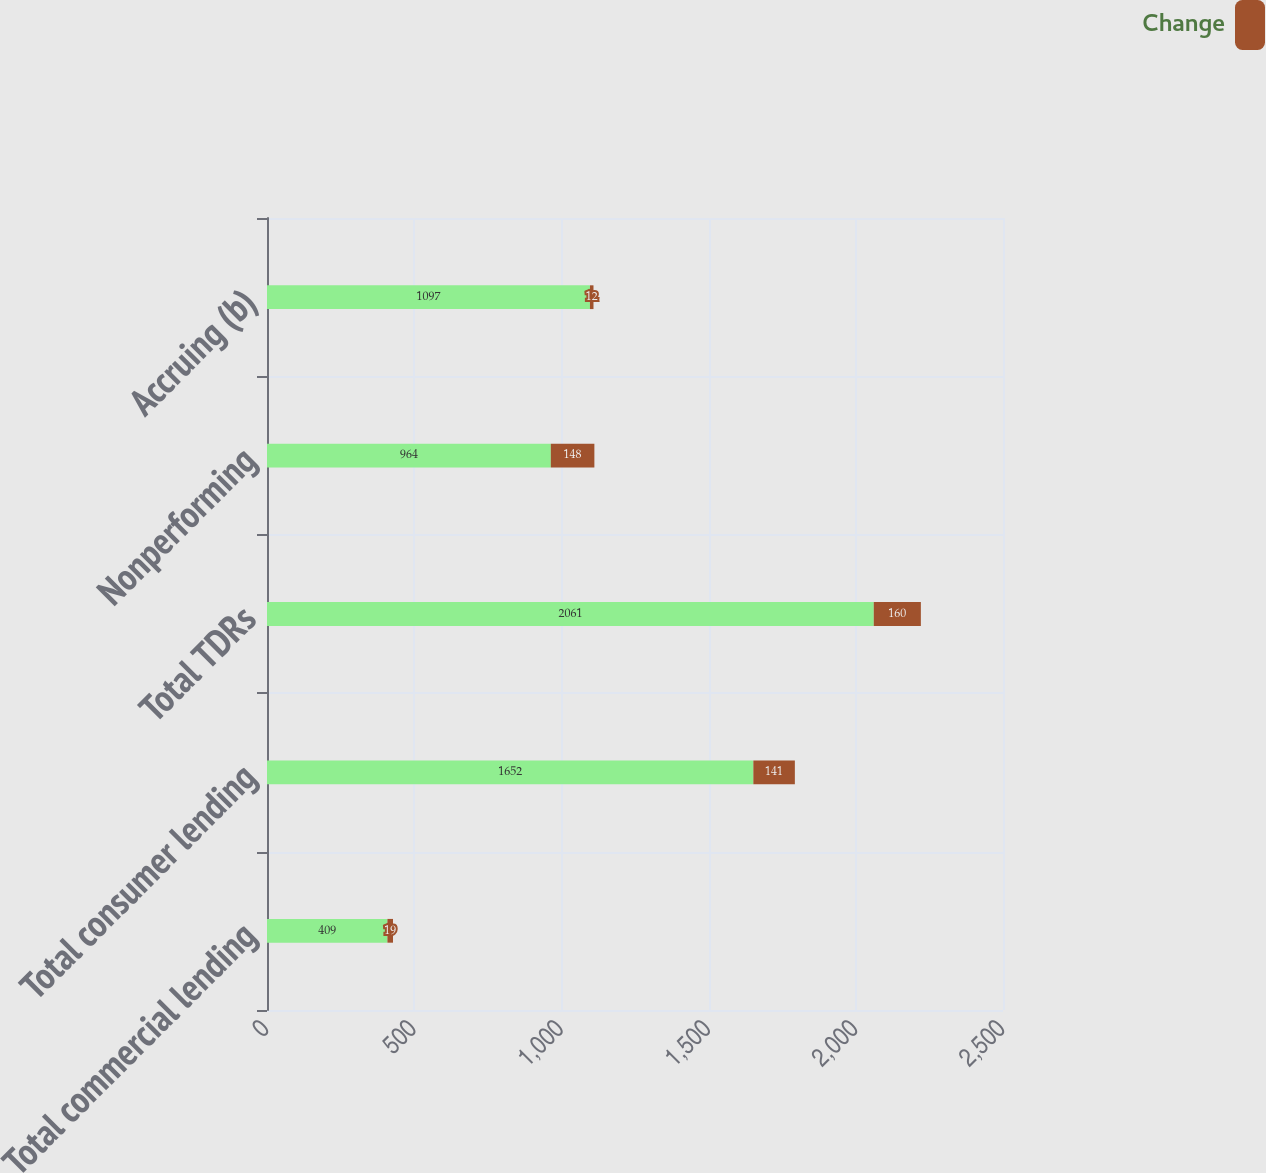Convert chart. <chart><loc_0><loc_0><loc_500><loc_500><stacked_bar_chart><ecel><fcel>Total commercial lending<fcel>Total consumer lending<fcel>Total TDRs<fcel>Nonperforming<fcel>Accruing (b)<nl><fcel>nan<fcel>409<fcel>1652<fcel>2061<fcel>964<fcel>1097<nl><fcel>Change<fcel>19<fcel>141<fcel>160<fcel>148<fcel>12<nl></chart> 